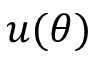<formula> <loc_0><loc_0><loc_500><loc_500>u ( \theta )</formula> 